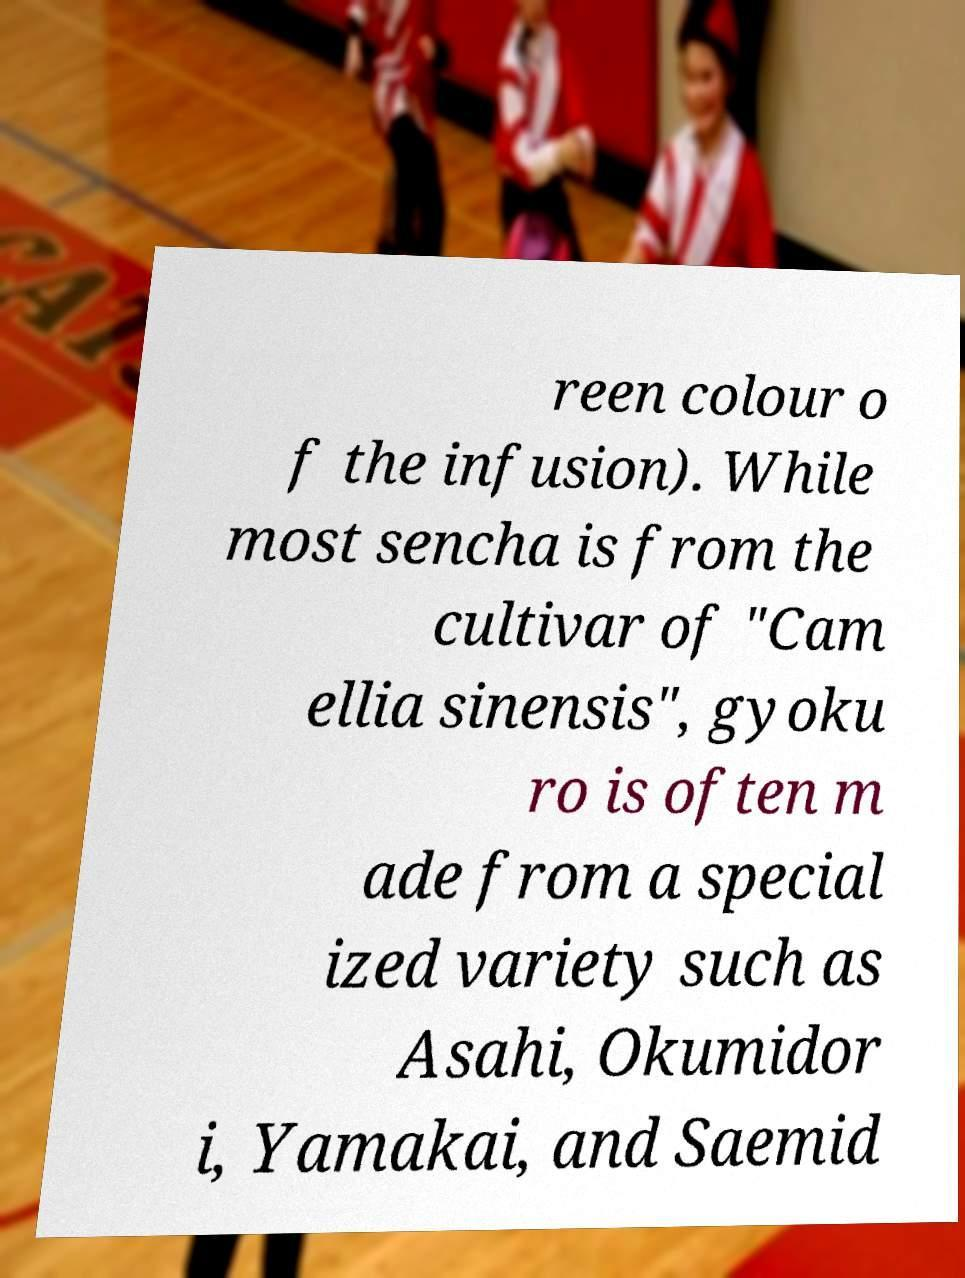There's text embedded in this image that I need extracted. Can you transcribe it verbatim? reen colour o f the infusion). While most sencha is from the cultivar of "Cam ellia sinensis", gyoku ro is often m ade from a special ized variety such as Asahi, Okumidor i, Yamakai, and Saemid 